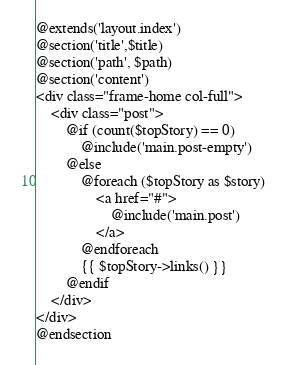Convert code to text. <code><loc_0><loc_0><loc_500><loc_500><_PHP_>@extends('layout.index')
@section('title',$title)
@section('path', $path)
@section('content')
<div class="frame-home col-full">
	<div class="post">
		@if (count($topStory) == 0)
			@include('main.post-empty')	
		@else
			@foreach ($topStory as $story)
				<a href="#">
					@include('main.post')
				</a>
			@endforeach
			{{ $topStory->links() }}
		@endif
	</div>
</div>
@endsection</code> 